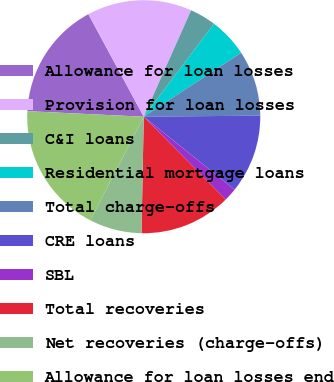Convert chart. <chart><loc_0><loc_0><loc_500><loc_500><pie_chart><fcel>Allowance for loan losses<fcel>Provision for loan losses<fcel>C&I loans<fcel>Residential mortgage loans<fcel>Total charge-offs<fcel>CRE loans<fcel>SBL<fcel>Total recoveries<fcel>Net recoveries (charge-offs)<fcel>Allowance for loan losses end<nl><fcel>16.36%<fcel>14.55%<fcel>3.64%<fcel>5.45%<fcel>9.09%<fcel>10.91%<fcel>1.82%<fcel>12.73%<fcel>7.27%<fcel>18.18%<nl></chart> 